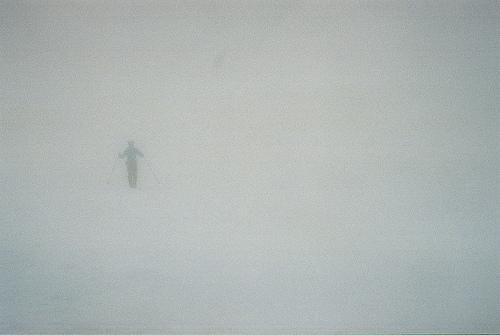Question: where is he skiing?
Choices:
A. A jump.
B. A slope.
C. A flat area.
D. A cross country skiing trail.
Answer with the letter. Answer: B Question: what is the person doing?
Choices:
A. Skiing.
B. Snowboarding.
C. Running.
D. Hiking.
Answer with the letter. Answer: A Question: who is in the picture?
Choices:
A. Snowboarder.
B. Hiker.
C. Runner.
D. Skier.
Answer with the letter. Answer: D Question: what is he skiing on?
Choices:
A. Snow.
B. Mud.
C. Water.
D. Ice.
Answer with the letter. Answer: A Question: when was the photo taken?
Choices:
A. Rain storm.
B. Snow storm.
C. Thunder storm.
D. Clear day.
Answer with the letter. Answer: B Question: why is it cloudy?
Choices:
A. Because it is raining.
B. Because it is foggy.
C. Because it is windy.
D. Because its snowing.
Answer with the letter. Answer: D 